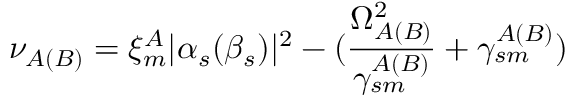Convert formula to latex. <formula><loc_0><loc_0><loc_500><loc_500>\nu _ { A ( B ) } = \xi _ { m } ^ { A } | \alpha _ { s } ( \beta _ { s } ) | ^ { 2 } - ( \frac { \Omega _ { A ( B ) } ^ { 2 } } { \gamma _ { s m } ^ { A ( B ) } } + \gamma _ { s m } ^ { A ( B ) } )</formula> 